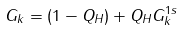Convert formula to latex. <formula><loc_0><loc_0><loc_500><loc_500>G _ { k } = ( 1 - Q _ { H } ) + Q _ { H } G _ { k } ^ { 1 s }</formula> 